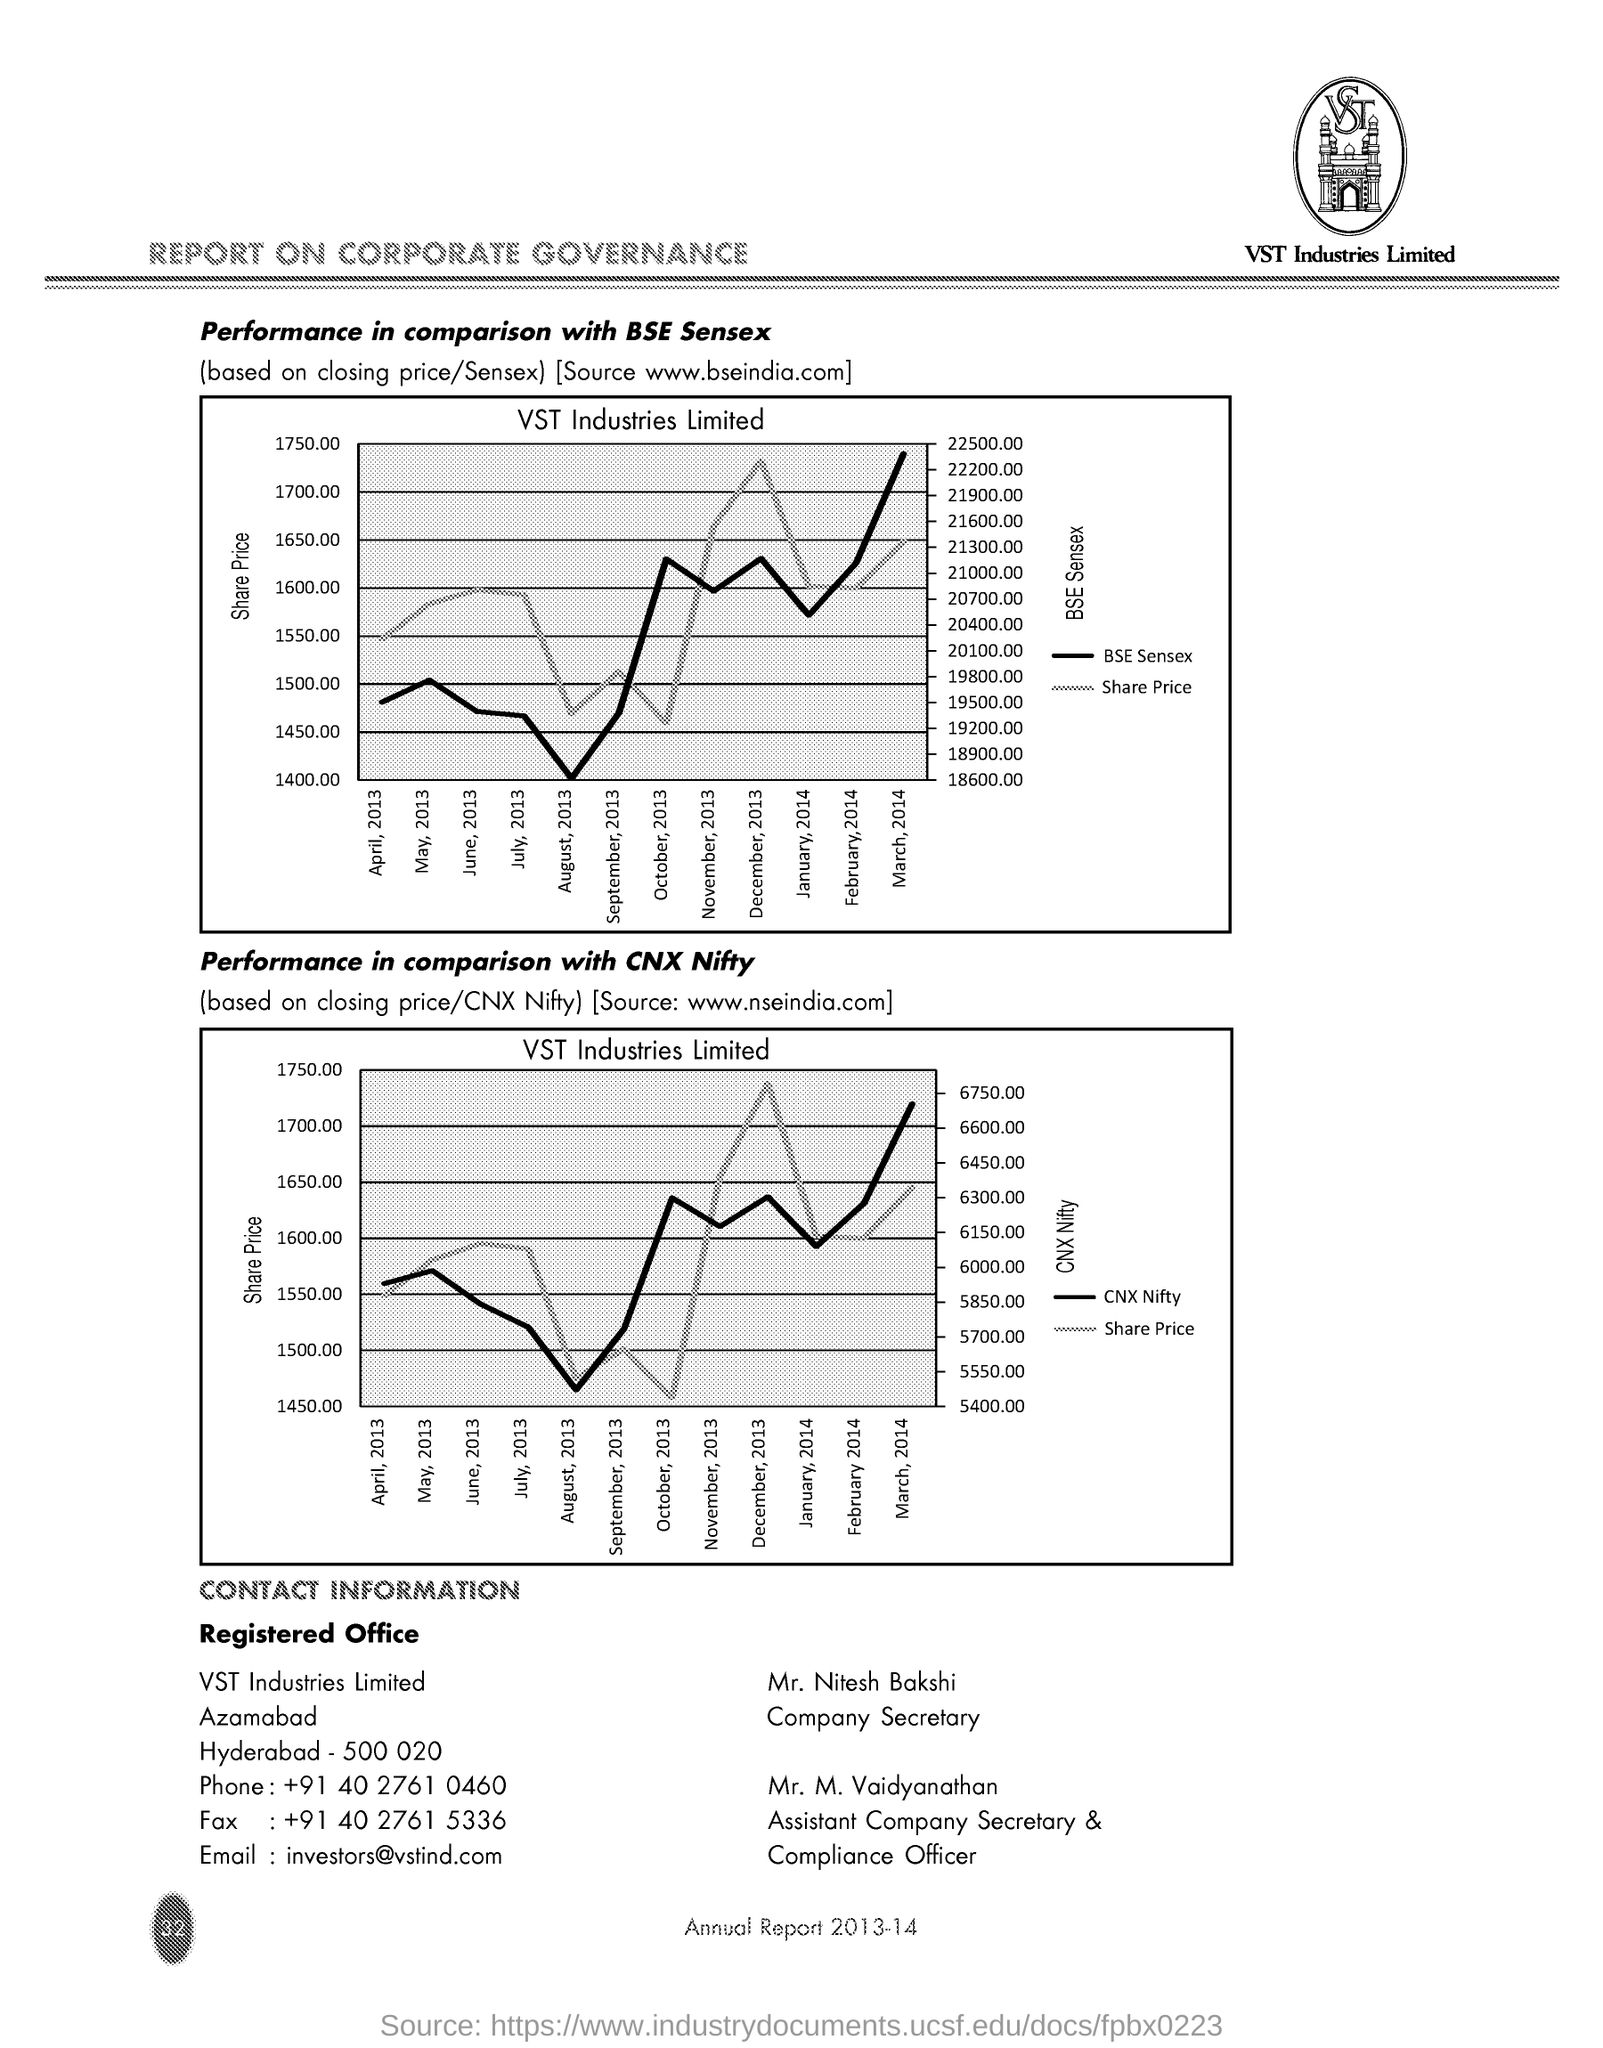Point out several critical features in this image. The email is [What is the email? investors@vstind.com..] The company secretary is Mr. Nitesh Bakshi. Mr. M. Vaidyanathan is the Assistant Company Secretary & Compliance Officer. The number 'What is the Fax? +91 40 2761 5336' is a fax number. The phone number is +91 40 2761 0460. 